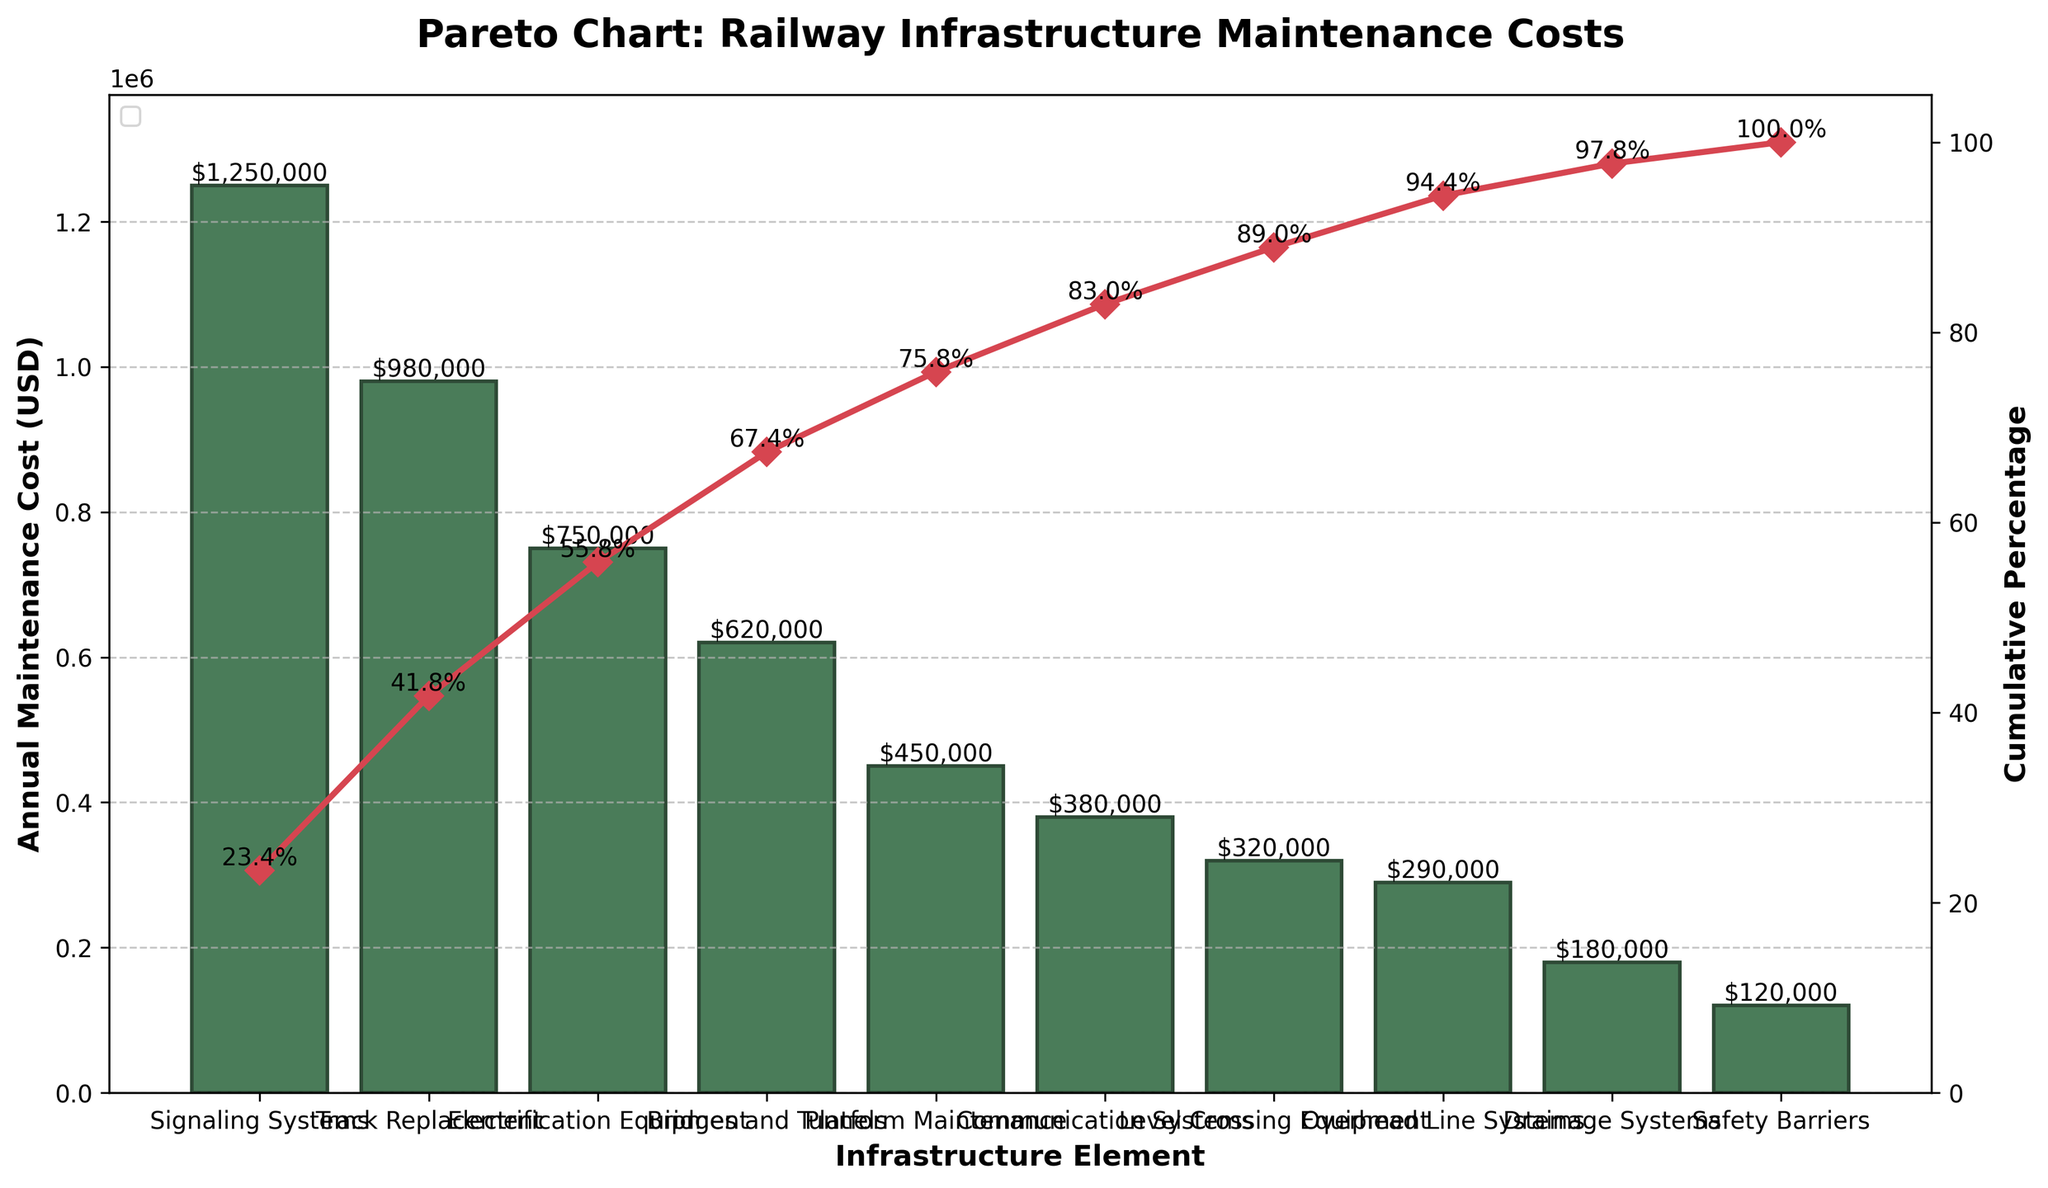What's the total annual maintenance cost for the top 3 most expensive infrastructure elements? Add the annual maintenance costs of the top 3 elements: Signaling Systems ($1,250,000), Track Replacement ($980,000), and Electrification Equipment ($750,000). Sum the values: $1,250,000 + $980,000 + $750,000 = $2,980,000
Answer: $2,980,000 What percentage of the total annual maintenance cost is contributed by Signaling Systems? First, determine the total annual maintenance cost by summing all elements. Then divide the cost of Signaling Systems by this total and multiply by 100 to get the percentage: (1,250,000 / (1,250,000 + 980,000 + 750,000 + 620,000 + 450,000 + 380,000 + 320,000 + 290,000 + 180,000 + 120,000)) * 100 = (1,250,000 / 5,340,000) * 100 ≈ 23.4%
Answer: 23.4% How many infrastructure elements contribute to approximately 80% of the total maintenance cost? Examine the cumulative percentage on the secondary y-axis. Check where the cumulative percentage reaches or exceeds 80%. For this chart, the top 5 elements (Signaling Systems, Track Replacement, Electrification Equipment, Bridges and Tunnels, Platform Maintenance) sum up to 80.4%.
Answer: 5 Which infrastructure element has the lowest annual maintenance cost, and what is that cost? Identify the bar with the smallest value in the chart, which is Safety Barriers. The corresponding annual maintenance cost is $120,000.
Answer: Safety Barriers, $120,000 What is the cumulative percentage for the fifth most expensive element? Identify the fifth element when ranked in descending order of cost, which is Platform Maintenance. The cumulative percentage for Platform Maintenance is shown on the line chart. It is around 80.4%.
Answer: 80.4% What is the difference in annual maintenance costs between Track Replacement and Bridges and Tunnels? Compare the values for Track Replacement ($980,000) and Bridges and Tunnels ($620,000) and find the difference: $980,000 - $620,000 = $360,000
Answer: $360,000 Which infrastructure elements have an annual maintenance cost above $500,000? Analyze the bars on the chart to find elements with costs exceeding $500,000. These are Signaling Systems ($1,250,000), Track Replacement ($980,000), Electrification Equipment ($750,000), and Bridges and Tunnels ($620,000).
Answer: Signaling Systems, Track Replacement, Electrification Equipment, Bridges and Tunnels What is the range of annual maintenance costs for the elements on this chart? Determine the minimum and maximum costs from the chart (Safety Barriers: $120,000 and Signaling Systems: $1,250,000). Calculate the range by subtracting the minimum from the maximum: $1,250,000 - $120,000 = $1,130,000.
Answer: $1,130,000 